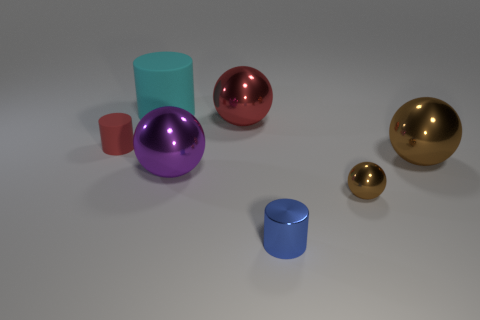Subtract all small metallic spheres. How many spheres are left? 3 Subtract all brown spheres. How many spheres are left? 2 Subtract all cylinders. How many objects are left? 4 Add 3 large brown things. How many objects exist? 10 Subtract 2 cylinders. How many cylinders are left? 1 Subtract all purple cylinders. Subtract all purple balls. How many cylinders are left? 3 Subtract all red balls. How many brown cylinders are left? 0 Subtract all blue metal cylinders. Subtract all big cyan cylinders. How many objects are left? 5 Add 5 tiny blue metallic cylinders. How many tiny blue metallic cylinders are left? 6 Add 6 small red spheres. How many small red spheres exist? 6 